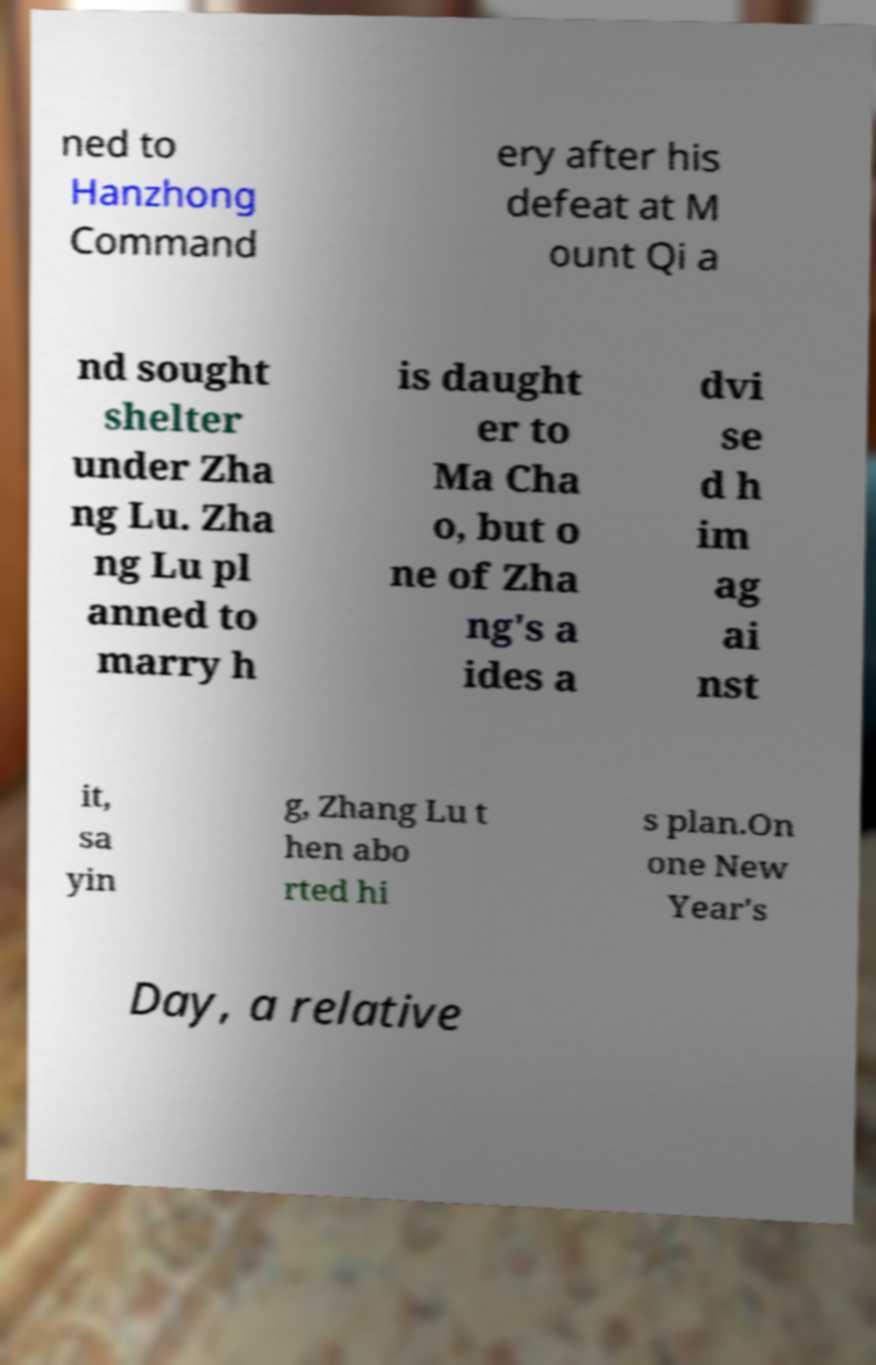Can you read and provide the text displayed in the image?This photo seems to have some interesting text. Can you extract and type it out for me? ned to Hanzhong Command ery after his defeat at M ount Qi a nd sought shelter under Zha ng Lu. Zha ng Lu pl anned to marry h is daught er to Ma Cha o, but o ne of Zha ng's a ides a dvi se d h im ag ai nst it, sa yin g, Zhang Lu t hen abo rted hi s plan.On one New Year's Day, a relative 